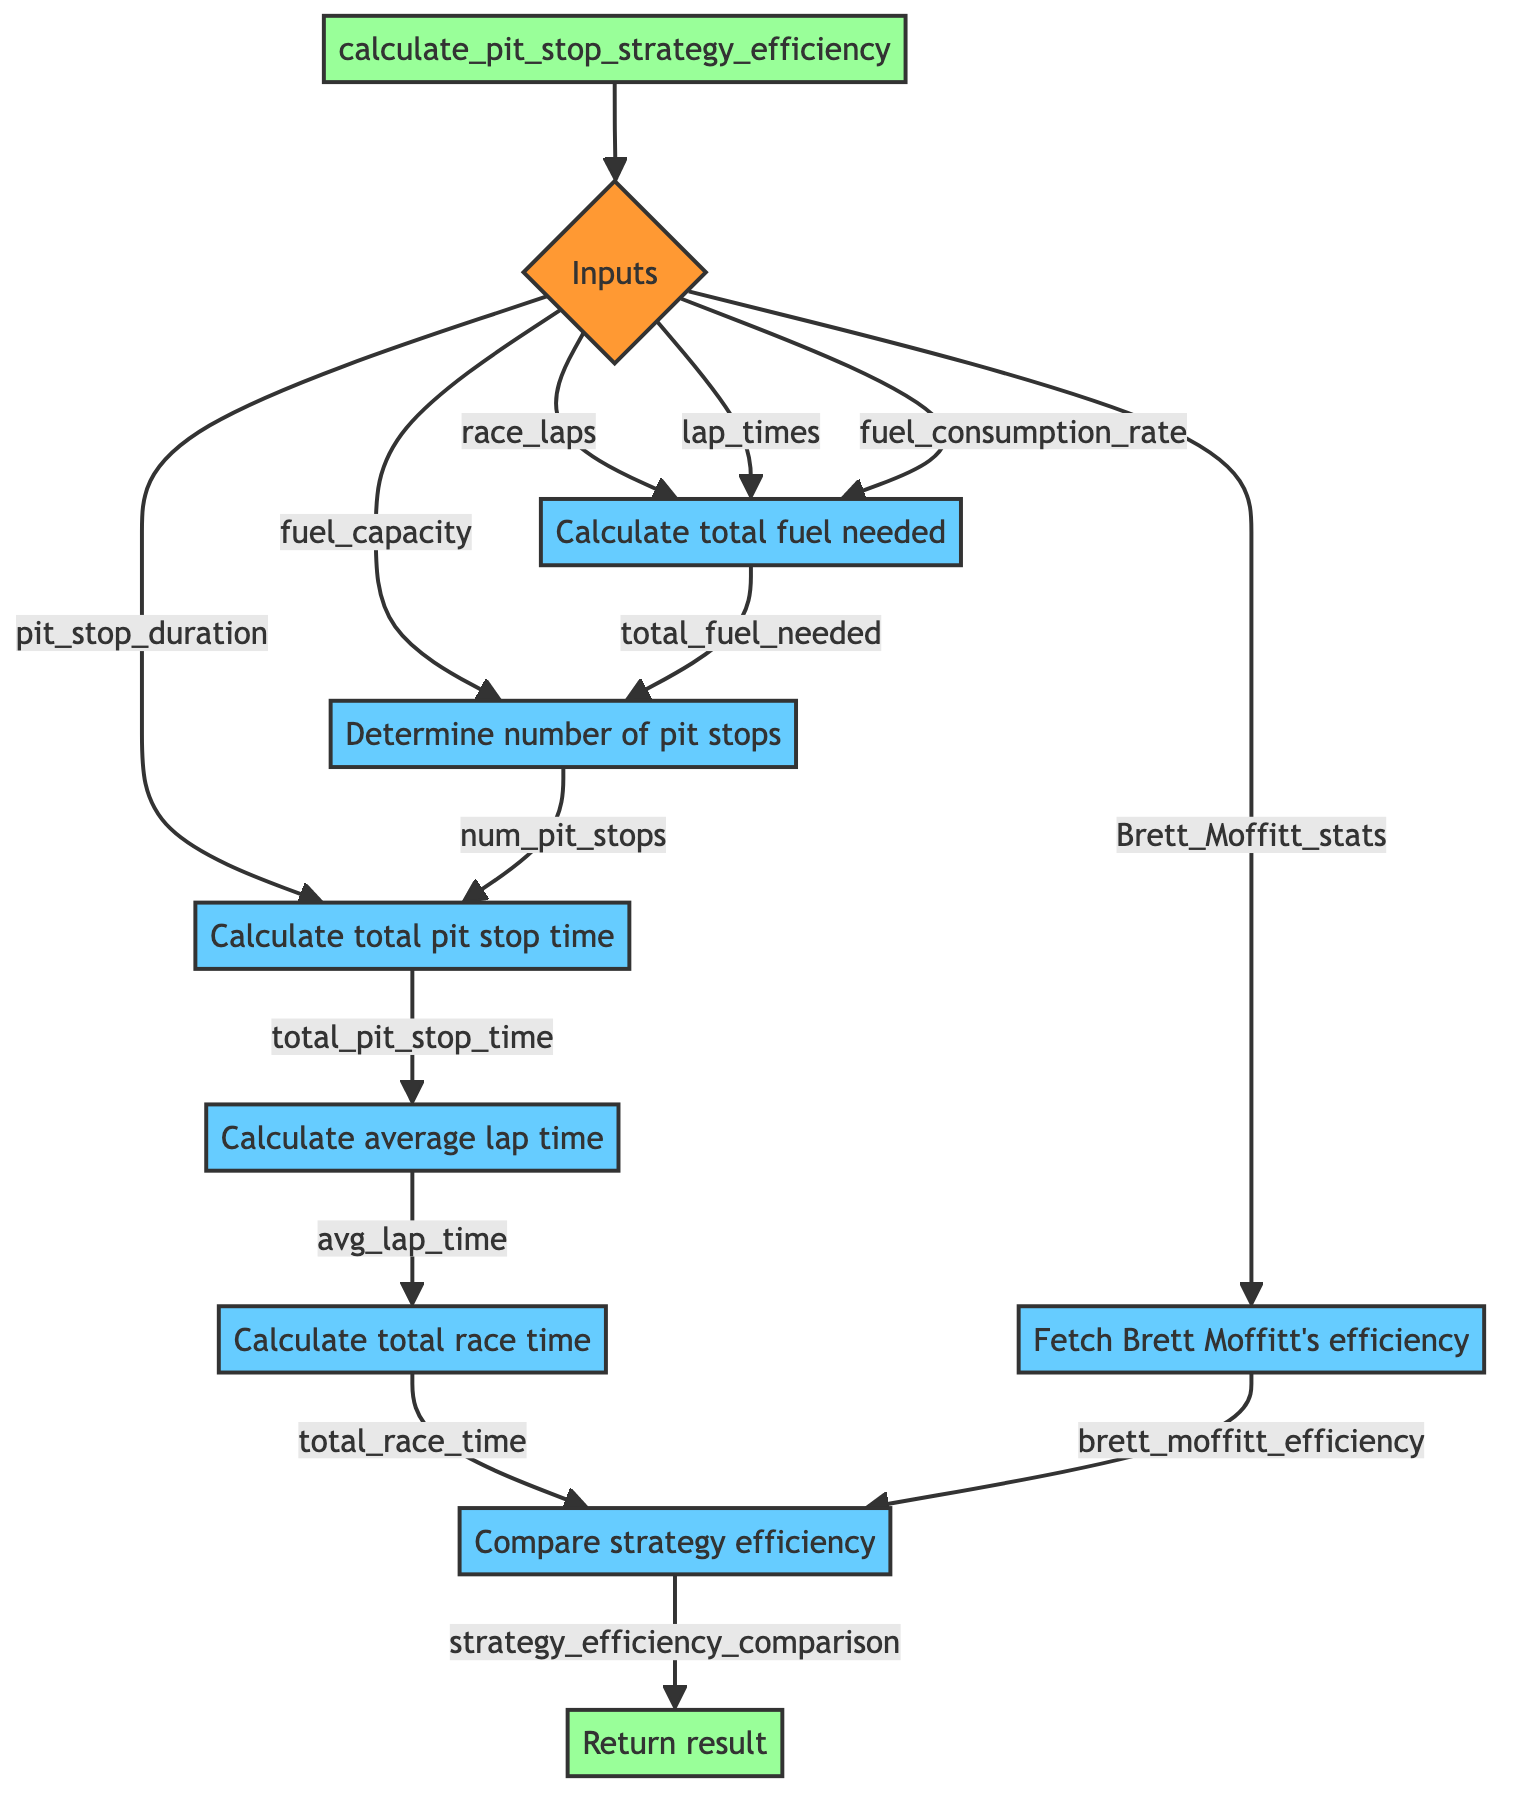What is the name of the function in this diagram? The function is labeled as "calculate_pit_stop_strategy_efficiency" at the top of the flowchart, clearly indicating that it represents the main process being described.
Answer: calculate pit stop strategy efficiency How many input parameters does the function take? The flowchart shows a single node labeled "Inputs" that branches out to six different input parameters: race_laps, lap_times, fuel_capacity, fuel_consumption_rate, pit_stop_duration, and Brett_Moffitt_stats. Thus, there are six input parameters.
Answer: six What is the first calculation performed in the function? According to the flowchart, the first operation after receiving inputs is "Calculate total fuel needed," which is the first step leading to subsequent computations.
Answer: Calculate total fuel needed Which step calculates the total race time? The flowchart labels a node that states "Calculate total race time." This node receives input from the "Calculate average lap time" step and the "Calculate total pit stop time" step, indicating it is the computation for total race time.
Answer: Calculate total race time What variable stores the total time spent in pit stops? The flowchart shows a node labeled "Calculate total time spent in pit stops," which operates based on the number of pit stops and the duration, and this computation stores the resulting value in the variable "total_pit_stop_time."
Answer: total_pit_stop_time How does the function determine the number of pit stops required? It computes the number of pit stops by taking the total fuel needed and dividing it by the fuel capacity, utilizing the formula "ceil(total_fuel_needed / fuel_capacity)" as shown in the flowchart.
Answer: ceil(total_fuel_needed / fuel_capacity) What is used to compare the efficiency of the strategy? The comparison is made by dividing the calculated total race time by "brett_moffitt_efficiency," which reflects how the calculated strategy relates to Brent Moffitt's historical efficiency.
Answer: total race time / brett_moffitt_efficiency What is the final output of the function? The output is represented in the last node of the flowchart, labeled as "Return result," which outputs the variable "strategy_efficiency_comparison," which is the final comparative efficiency result of the pit stop strategy.
Answer: strategy_efficiency_comparison What does the function fetch regarding Brent Moffitt? The flowchart shows a specific step that states "Fetch Brett Moffitt's historical pit stop efficiency," indicating that this step retrieves relevant historical data on Moffitt's performance during pit stops.
Answer: historical pit stop efficiency How many steps are there to calculate pit stop strategy efficiency? Reviewing the flowchart, there are a total of eight steps that lead from input to output, with each node representing a distinct calculation or operation in the overall process.
Answer: eight 